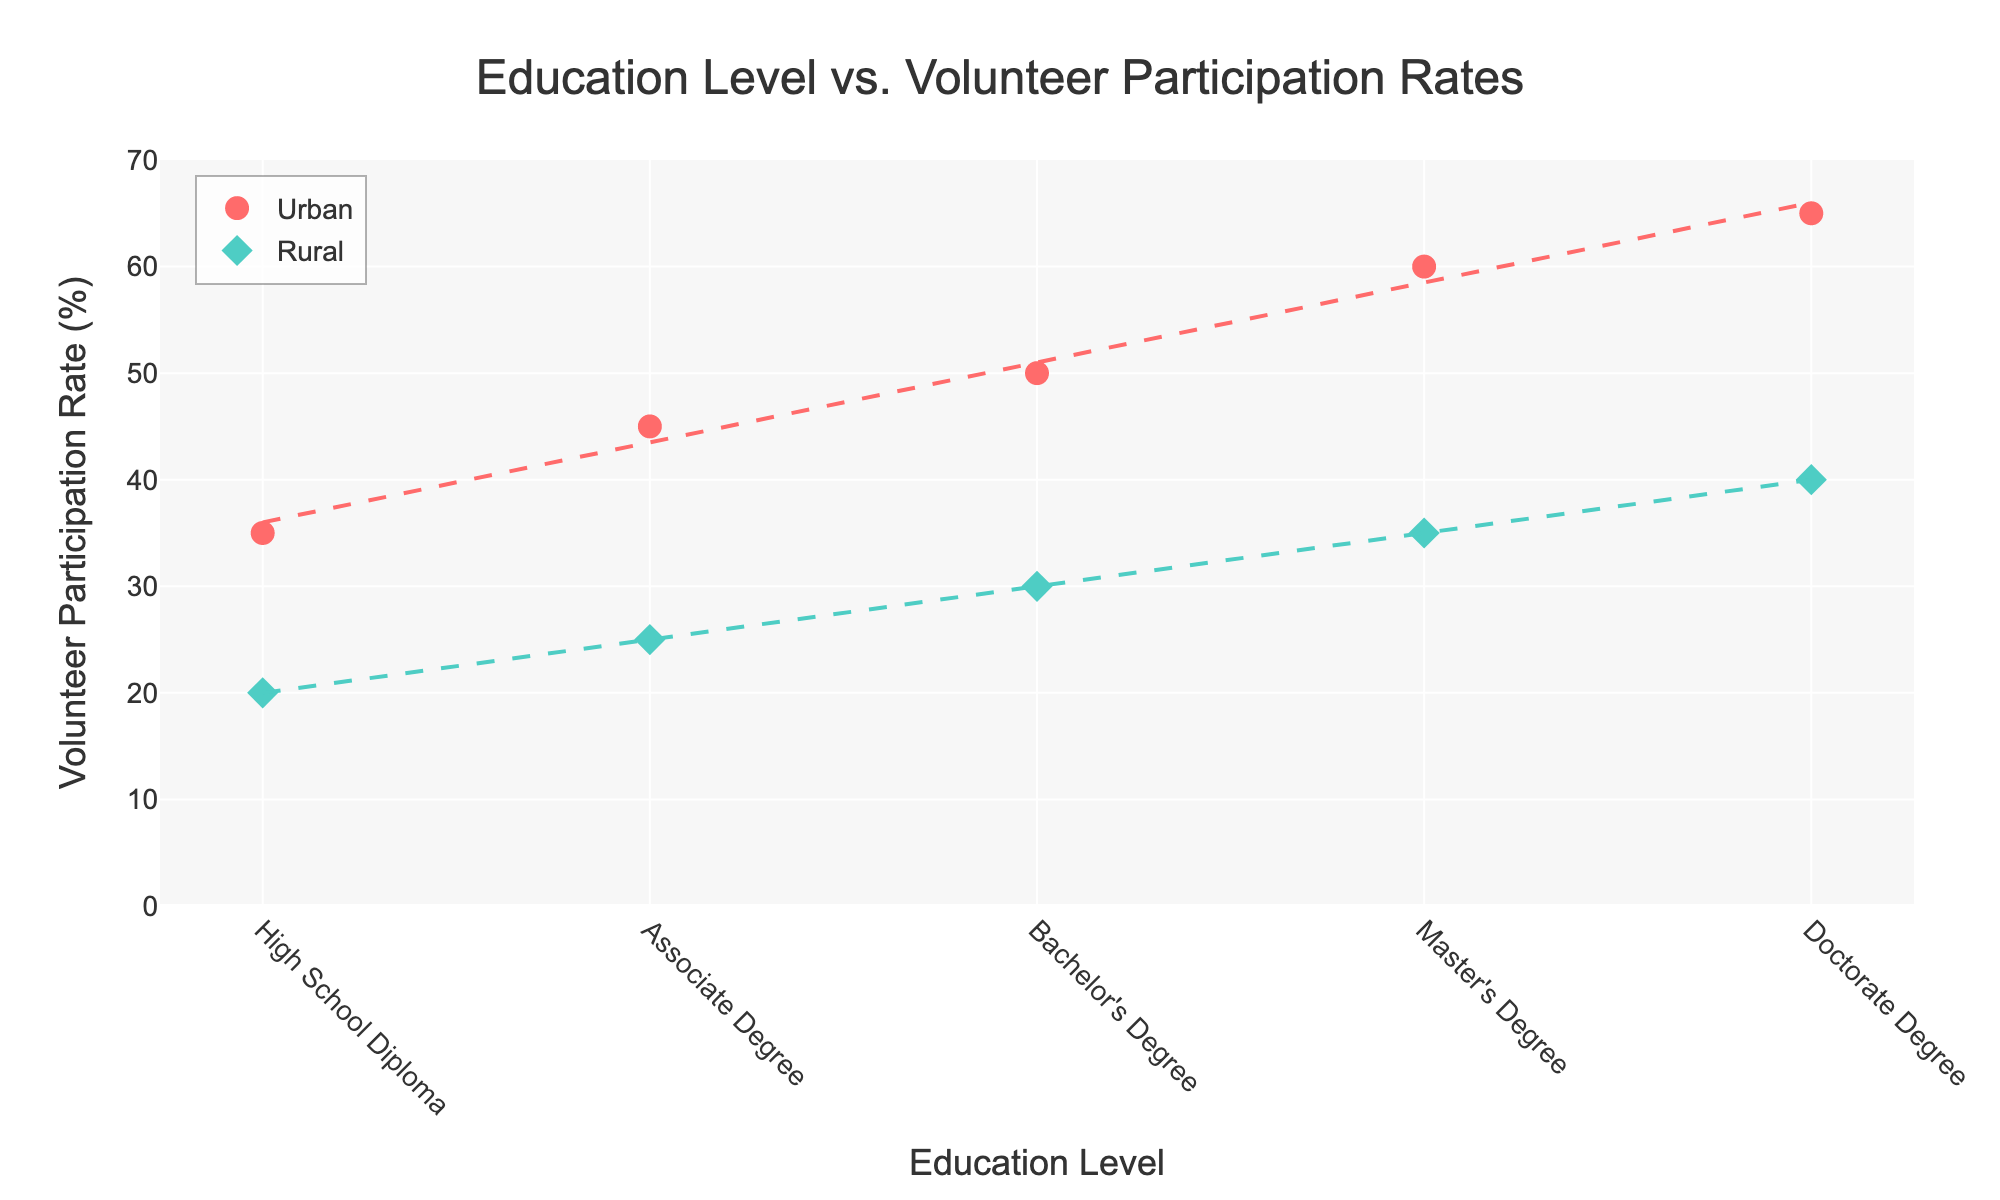what is the title of the figure? The title is the text prominently displayed at the top of the figure, usually describing what the data is about. In this case, it is likely to be related to Education Level and Volunteer Participation Rates.
Answer: Education Level vs. Volunteer Participation Rates what is the color of the urban area data points? The urban area data points are represented by a specific color in the scatter plot, which can be identified visually.
Answer: Red which area type shows a higher volunteer participation rate for the bachelor's degree level? Comparing the volunteer participation rates for the Bachelor's Degree level between Urban and Rural areas is straightforward by looking at the corresponding points on the plot.
Answer: Urban how many data points are there for rural areas? By counting the data points (diamonds) that are colored for rural areas, we can determine their total number.
Answer: 5 what is the range of the y-axis? The range can be identified by looking at the lowest and highest tick values on the y-axis of the scatter plot.
Answer: 0 to 70 is there a general trend of volunteer participation rate with increasing education level for urban areas? Observe the trend line for the urban data points. If it's generally upward sloping, it indicates an increasing trend.
Answer: Yes what's the difference in the volunteer participation rate between urban and rural areas for doctorate degree holders? Subtract the volunteer participation rate for rural areas from the rate for urban areas at the Doctorate Degree level.
Answer: 25 which degree level has the largest difference in volunteer participation rates between urban and rural areas? Calculate the differences in participation rates for each degree level and compare them to find the largest one.
Answer: Doctorate Degree what is the average volunteer participation rate for rural areas? Sum all the volunteer participation rates for rural areas and divide by the number of rural data points.
Answer: 30 do urban or rural areas have a steeper trend line for volunteer participation rates? Compare the slopes of the trend lines (the degree of the angle). The steeper one indicates a faster rate of change in participation rates.
Answer: Urban 